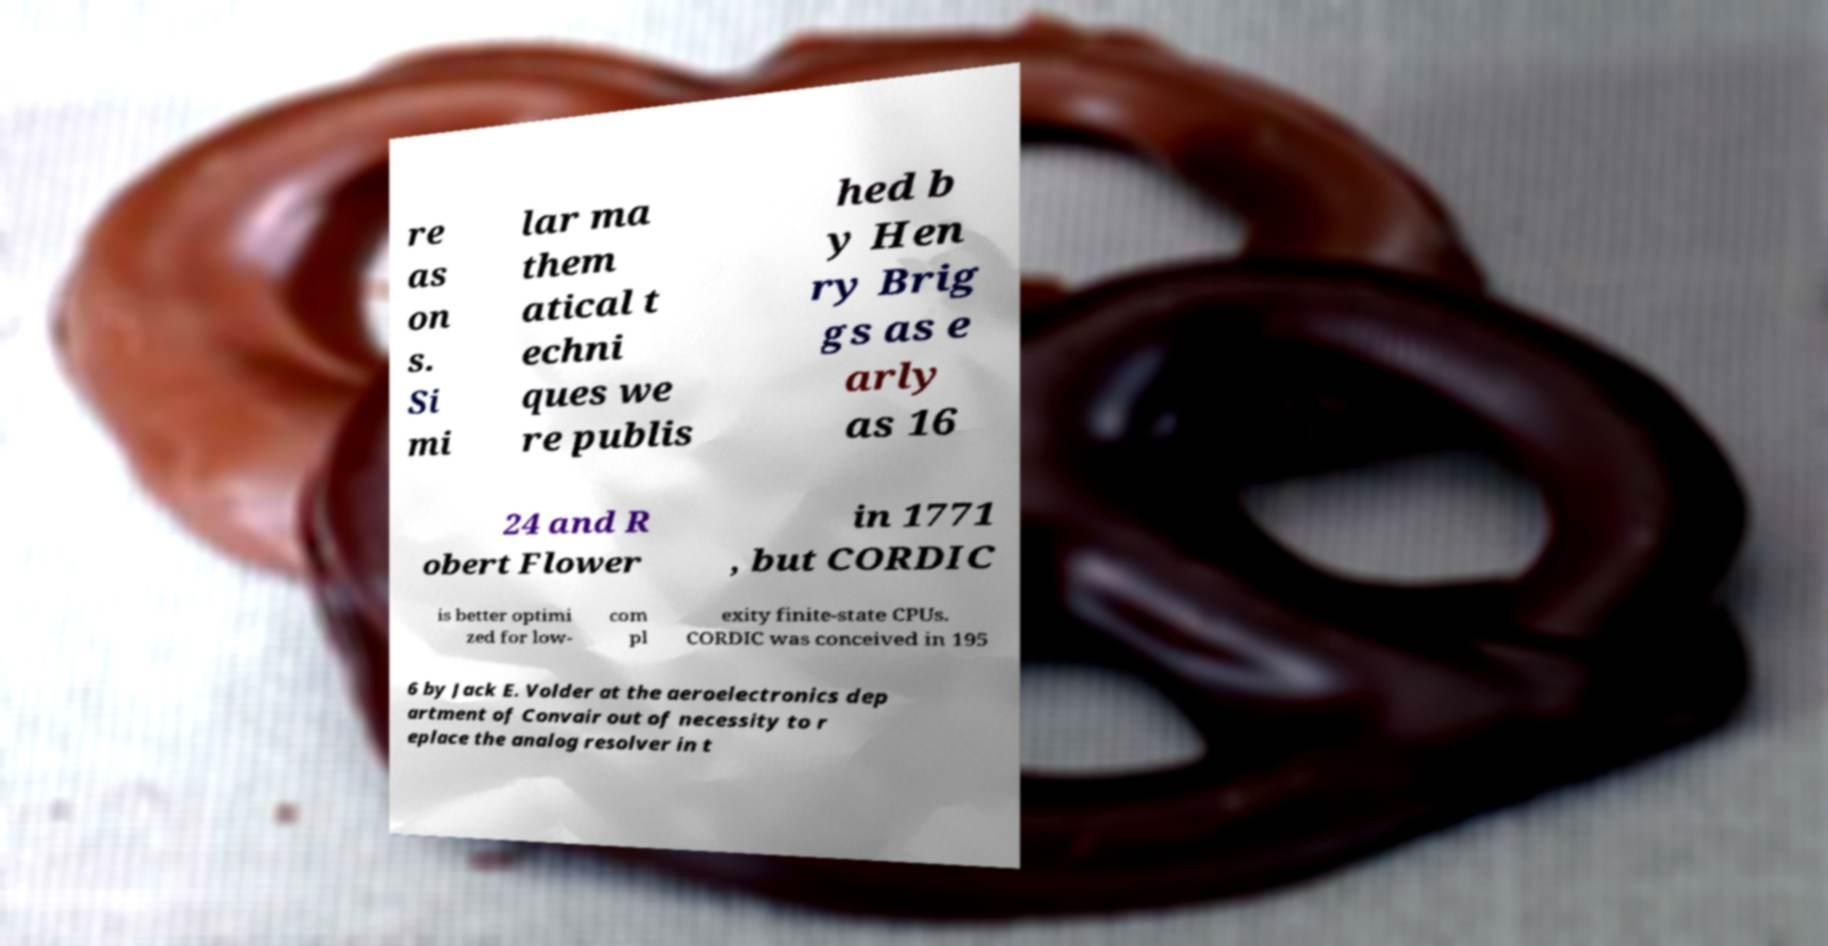I need the written content from this picture converted into text. Can you do that? re as on s. Si mi lar ma them atical t echni ques we re publis hed b y Hen ry Brig gs as e arly as 16 24 and R obert Flower in 1771 , but CORDIC is better optimi zed for low- com pl exity finite-state CPUs. CORDIC was conceived in 195 6 by Jack E. Volder at the aeroelectronics dep artment of Convair out of necessity to r eplace the analog resolver in t 